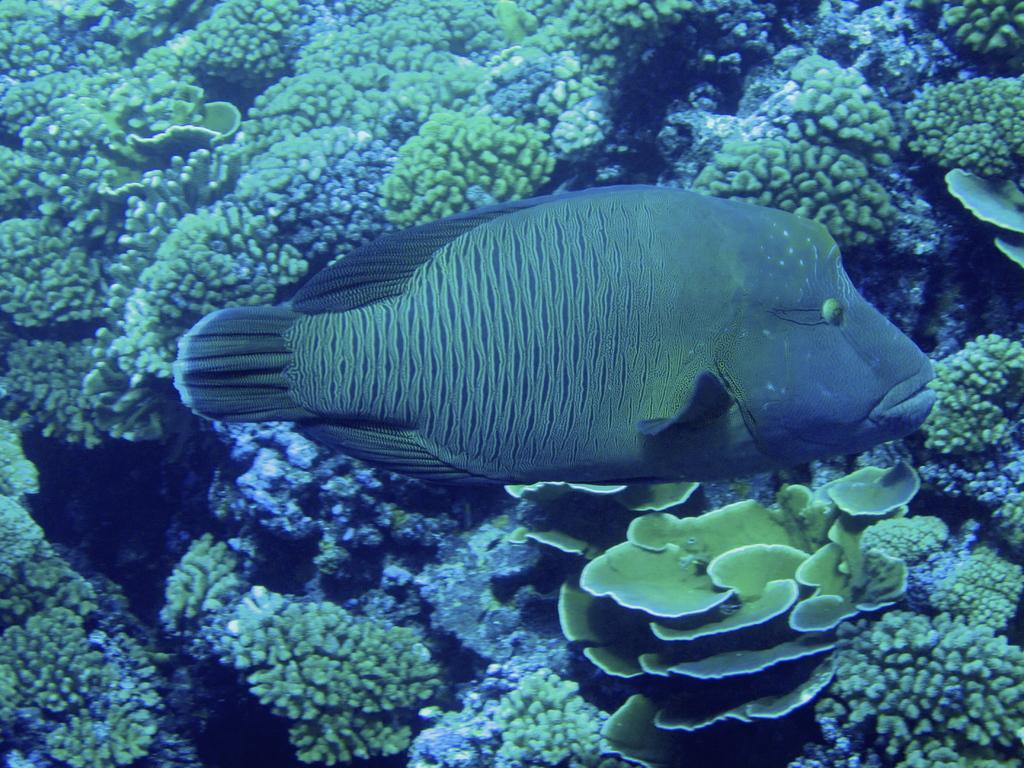Where was the picture taken? The picture was taken inside water. What is the main subject in the center of the image? There is a fish in the center of the image. What can be seen in the background of the image? There are water plants in the background of the image. How many dinosaurs can be seen in the image? There are no dinosaurs present in the image. What type of tub is visible in the image? There is no tub present in the image. 